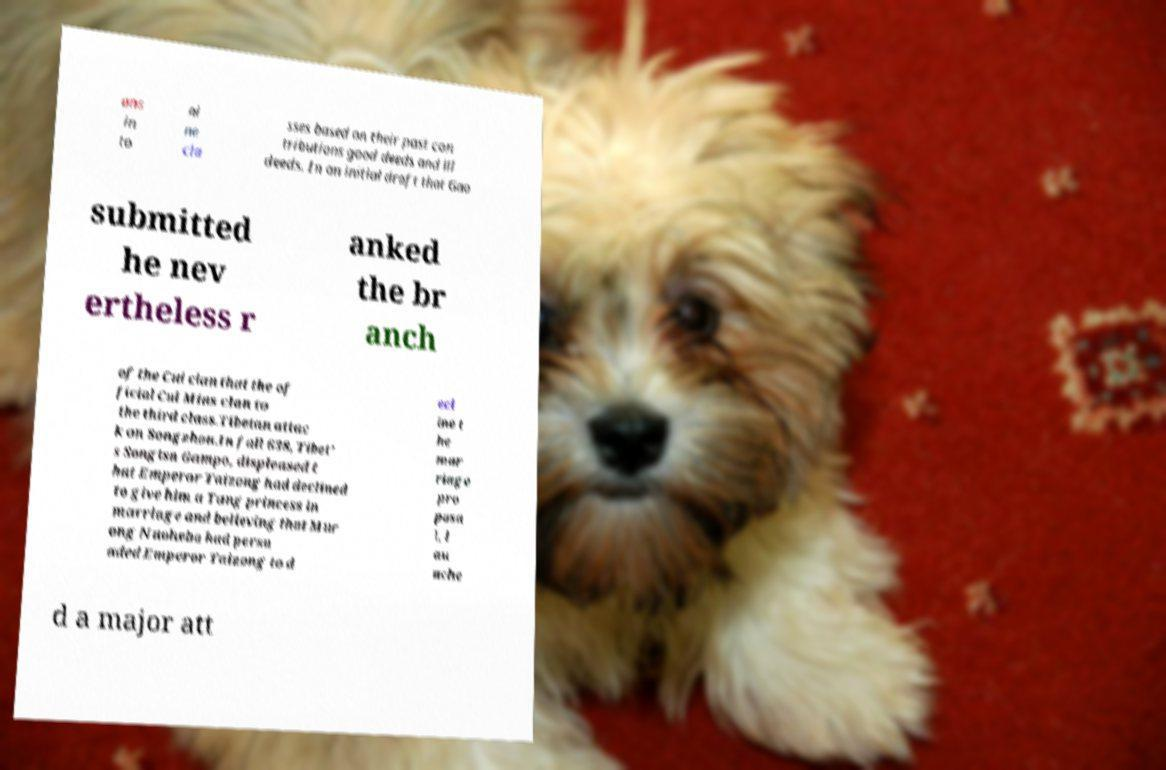There's text embedded in this image that I need extracted. Can you transcribe it verbatim? ans in to ni ne cla sses based on their past con tributions good deeds and ill deeds. In an initial draft that Gao submitted he nev ertheless r anked the br anch of the Cui clan that the of ficial Cui Mins clan to the third class.Tibetan attac k on Songzhou.In fall 638, Tibet' s Songtsn Gampo, displeased t hat Emperor Taizong had declined to give him a Tang princess in marriage and believing that Mur ong Nuohebo had persu aded Emperor Taizong to d ecl ine t he mar riage pro posa l, l au nche d a major att 